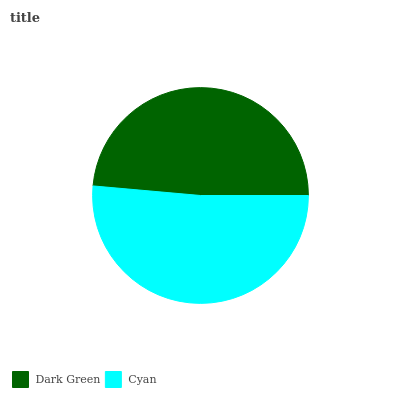Is Dark Green the minimum?
Answer yes or no. Yes. Is Cyan the maximum?
Answer yes or no. Yes. Is Cyan the minimum?
Answer yes or no. No. Is Cyan greater than Dark Green?
Answer yes or no. Yes. Is Dark Green less than Cyan?
Answer yes or no. Yes. Is Dark Green greater than Cyan?
Answer yes or no. No. Is Cyan less than Dark Green?
Answer yes or no. No. Is Cyan the high median?
Answer yes or no. Yes. Is Dark Green the low median?
Answer yes or no. Yes. Is Dark Green the high median?
Answer yes or no. No. Is Cyan the low median?
Answer yes or no. No. 